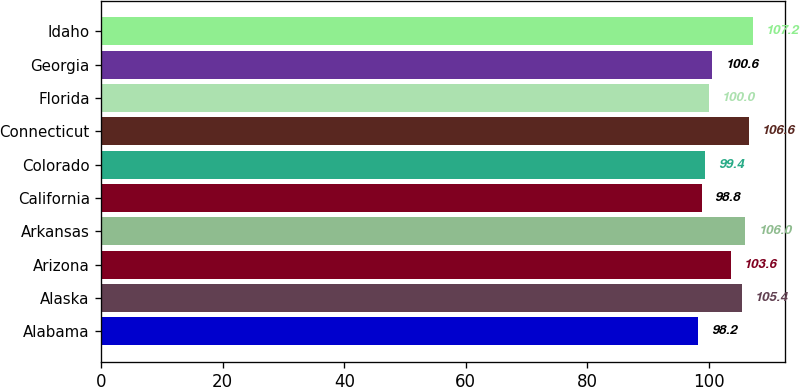Convert chart to OTSL. <chart><loc_0><loc_0><loc_500><loc_500><bar_chart><fcel>Alabama<fcel>Alaska<fcel>Arizona<fcel>Arkansas<fcel>California<fcel>Colorado<fcel>Connecticut<fcel>Florida<fcel>Georgia<fcel>Idaho<nl><fcel>98.2<fcel>105.4<fcel>103.6<fcel>106<fcel>98.8<fcel>99.4<fcel>106.6<fcel>100<fcel>100.6<fcel>107.2<nl></chart> 